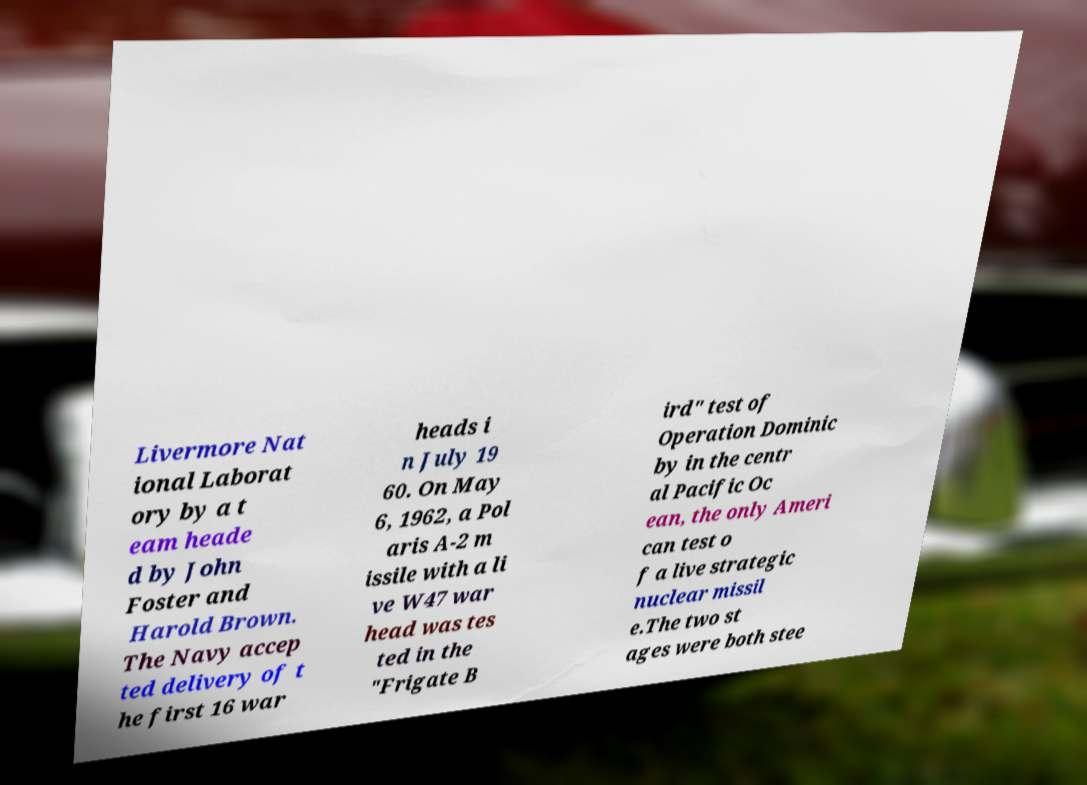I need the written content from this picture converted into text. Can you do that? Livermore Nat ional Laborat ory by a t eam heade d by John Foster and Harold Brown. The Navy accep ted delivery of t he first 16 war heads i n July 19 60. On May 6, 1962, a Pol aris A-2 m issile with a li ve W47 war head was tes ted in the "Frigate B ird" test of Operation Dominic by in the centr al Pacific Oc ean, the only Ameri can test o f a live strategic nuclear missil e.The two st ages were both stee 